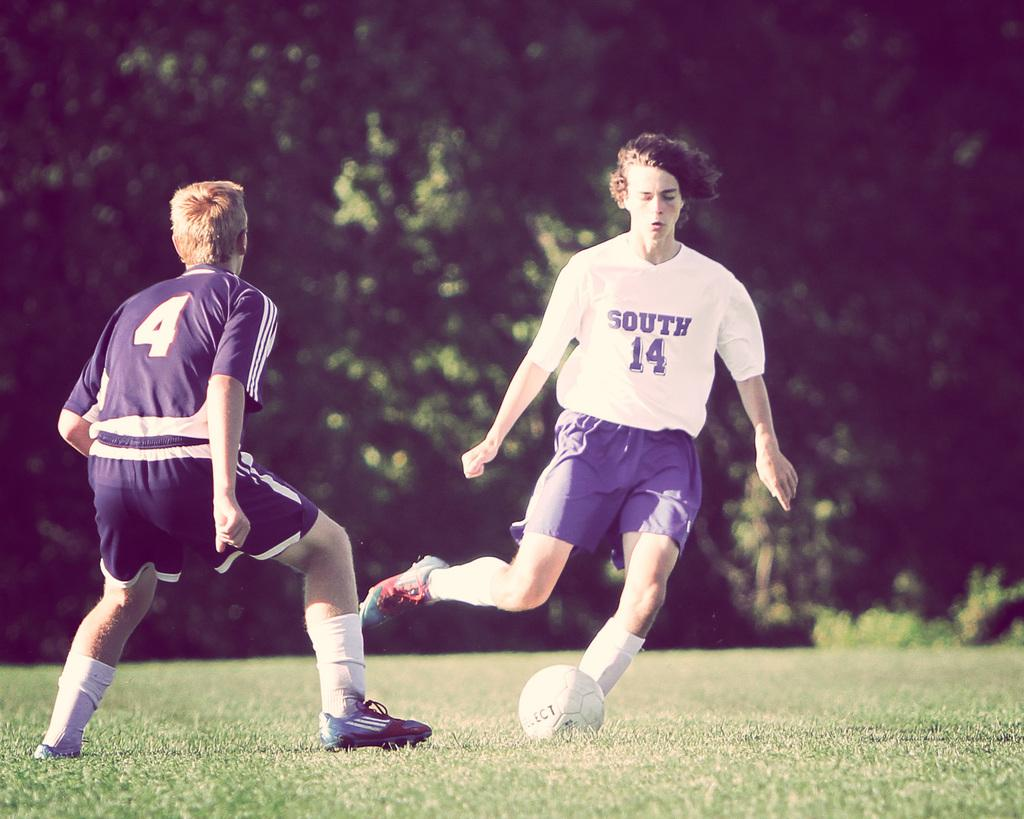Provide a one-sentence caption for the provided image. A soccer player is wearing a shirt with South and the number 14 on it. 